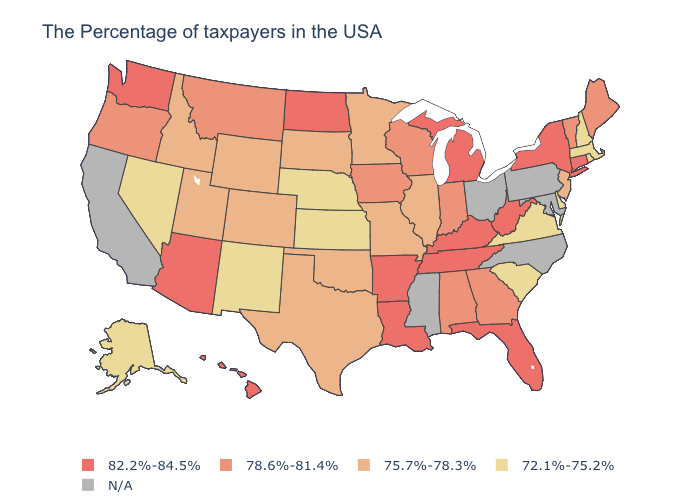What is the highest value in states that border Wyoming?
Concise answer only. 78.6%-81.4%. What is the lowest value in the West?
Concise answer only. 72.1%-75.2%. Does the first symbol in the legend represent the smallest category?
Answer briefly. No. Name the states that have a value in the range 75.7%-78.3%?
Concise answer only. New Jersey, Illinois, Missouri, Minnesota, Oklahoma, Texas, South Dakota, Wyoming, Colorado, Utah, Idaho. Name the states that have a value in the range 75.7%-78.3%?
Concise answer only. New Jersey, Illinois, Missouri, Minnesota, Oklahoma, Texas, South Dakota, Wyoming, Colorado, Utah, Idaho. What is the value of Illinois?
Short answer required. 75.7%-78.3%. Does Texas have the highest value in the USA?
Write a very short answer. No. What is the value of Connecticut?
Concise answer only. 82.2%-84.5%. What is the value of West Virginia?
Give a very brief answer. 82.2%-84.5%. What is the value of Florida?
Short answer required. 82.2%-84.5%. What is the value of Rhode Island?
Be succinct. 72.1%-75.2%. Name the states that have a value in the range 72.1%-75.2%?
Short answer required. Massachusetts, Rhode Island, New Hampshire, Delaware, Virginia, South Carolina, Kansas, Nebraska, New Mexico, Nevada, Alaska. 